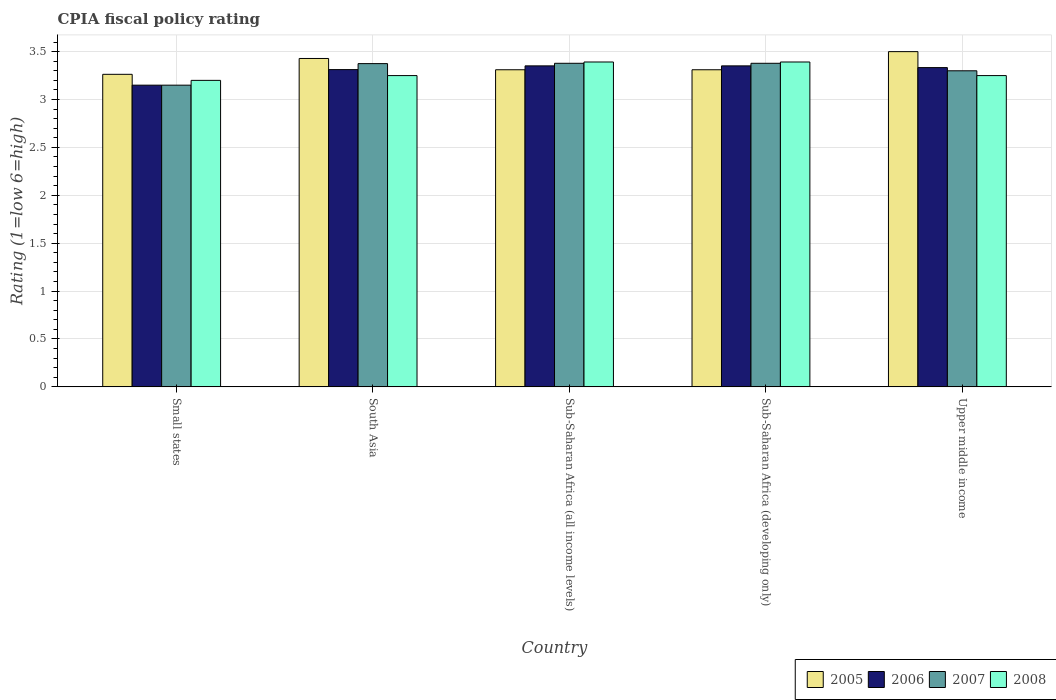How many groups of bars are there?
Keep it short and to the point. 5. How many bars are there on the 5th tick from the left?
Your response must be concise. 4. How many bars are there on the 5th tick from the right?
Give a very brief answer. 4. What is the label of the 3rd group of bars from the left?
Your response must be concise. Sub-Saharan Africa (all income levels). In how many cases, is the number of bars for a given country not equal to the number of legend labels?
Your response must be concise. 0. What is the CPIA rating in 2006 in Small states?
Offer a very short reply. 3.15. Across all countries, what is the maximum CPIA rating in 2006?
Offer a terse response. 3.35. Across all countries, what is the minimum CPIA rating in 2006?
Provide a short and direct response. 3.15. In which country was the CPIA rating in 2005 maximum?
Give a very brief answer. Upper middle income. In which country was the CPIA rating in 2007 minimum?
Ensure brevity in your answer.  Small states. What is the total CPIA rating in 2005 in the graph?
Provide a succinct answer. 16.81. What is the difference between the CPIA rating in 2006 in Small states and that in South Asia?
Your response must be concise. -0.16. What is the difference between the CPIA rating in 2008 in Sub-Saharan Africa (developing only) and the CPIA rating in 2007 in Sub-Saharan Africa (all income levels)?
Your response must be concise. 0.01. What is the average CPIA rating in 2008 per country?
Give a very brief answer. 3.3. What is the difference between the CPIA rating of/in 2006 and CPIA rating of/in 2007 in Sub-Saharan Africa (developing only)?
Your answer should be very brief. -0.03. Is the CPIA rating in 2007 in Sub-Saharan Africa (developing only) less than that in Upper middle income?
Keep it short and to the point. No. Is the difference between the CPIA rating in 2006 in Sub-Saharan Africa (all income levels) and Sub-Saharan Africa (developing only) greater than the difference between the CPIA rating in 2007 in Sub-Saharan Africa (all income levels) and Sub-Saharan Africa (developing only)?
Provide a short and direct response. No. What is the difference between the highest and the second highest CPIA rating in 2006?
Your answer should be compact. -0.02. What is the difference between the highest and the lowest CPIA rating in 2006?
Your answer should be very brief. 0.2. In how many countries, is the CPIA rating in 2008 greater than the average CPIA rating in 2008 taken over all countries?
Your response must be concise. 2. Is it the case that in every country, the sum of the CPIA rating in 2006 and CPIA rating in 2005 is greater than the sum of CPIA rating in 2008 and CPIA rating in 2007?
Give a very brief answer. No. What does the 2nd bar from the right in Sub-Saharan Africa (all income levels) represents?
Offer a very short reply. 2007. Is it the case that in every country, the sum of the CPIA rating in 2006 and CPIA rating in 2008 is greater than the CPIA rating in 2007?
Give a very brief answer. Yes. Are all the bars in the graph horizontal?
Provide a succinct answer. No. What is the difference between two consecutive major ticks on the Y-axis?
Make the answer very short. 0.5. Are the values on the major ticks of Y-axis written in scientific E-notation?
Give a very brief answer. No. Does the graph contain grids?
Provide a succinct answer. Yes. Where does the legend appear in the graph?
Offer a very short reply. Bottom right. How are the legend labels stacked?
Make the answer very short. Horizontal. What is the title of the graph?
Provide a short and direct response. CPIA fiscal policy rating. Does "1999" appear as one of the legend labels in the graph?
Provide a short and direct response. No. What is the label or title of the X-axis?
Provide a succinct answer. Country. What is the Rating (1=low 6=high) in 2005 in Small states?
Your response must be concise. 3.26. What is the Rating (1=low 6=high) in 2006 in Small states?
Ensure brevity in your answer.  3.15. What is the Rating (1=low 6=high) of 2007 in Small states?
Offer a very short reply. 3.15. What is the Rating (1=low 6=high) in 2008 in Small states?
Offer a terse response. 3.2. What is the Rating (1=low 6=high) in 2005 in South Asia?
Offer a terse response. 3.43. What is the Rating (1=low 6=high) of 2006 in South Asia?
Your answer should be compact. 3.31. What is the Rating (1=low 6=high) of 2007 in South Asia?
Give a very brief answer. 3.38. What is the Rating (1=low 6=high) in 2005 in Sub-Saharan Africa (all income levels)?
Keep it short and to the point. 3.31. What is the Rating (1=low 6=high) in 2006 in Sub-Saharan Africa (all income levels)?
Provide a short and direct response. 3.35. What is the Rating (1=low 6=high) of 2007 in Sub-Saharan Africa (all income levels)?
Offer a very short reply. 3.38. What is the Rating (1=low 6=high) in 2008 in Sub-Saharan Africa (all income levels)?
Provide a succinct answer. 3.39. What is the Rating (1=low 6=high) in 2005 in Sub-Saharan Africa (developing only)?
Provide a short and direct response. 3.31. What is the Rating (1=low 6=high) of 2006 in Sub-Saharan Africa (developing only)?
Ensure brevity in your answer.  3.35. What is the Rating (1=low 6=high) in 2007 in Sub-Saharan Africa (developing only)?
Offer a terse response. 3.38. What is the Rating (1=low 6=high) in 2008 in Sub-Saharan Africa (developing only)?
Your answer should be very brief. 3.39. What is the Rating (1=low 6=high) of 2005 in Upper middle income?
Your answer should be compact. 3.5. What is the Rating (1=low 6=high) in 2006 in Upper middle income?
Give a very brief answer. 3.33. Across all countries, what is the maximum Rating (1=low 6=high) in 2006?
Your answer should be compact. 3.35. Across all countries, what is the maximum Rating (1=low 6=high) of 2007?
Keep it short and to the point. 3.38. Across all countries, what is the maximum Rating (1=low 6=high) in 2008?
Give a very brief answer. 3.39. Across all countries, what is the minimum Rating (1=low 6=high) of 2005?
Your response must be concise. 3.26. Across all countries, what is the minimum Rating (1=low 6=high) of 2006?
Ensure brevity in your answer.  3.15. Across all countries, what is the minimum Rating (1=low 6=high) in 2007?
Offer a very short reply. 3.15. What is the total Rating (1=low 6=high) in 2005 in the graph?
Offer a terse response. 16.81. What is the total Rating (1=low 6=high) of 2006 in the graph?
Provide a short and direct response. 16.5. What is the total Rating (1=low 6=high) in 2007 in the graph?
Keep it short and to the point. 16.58. What is the total Rating (1=low 6=high) in 2008 in the graph?
Ensure brevity in your answer.  16.48. What is the difference between the Rating (1=low 6=high) in 2005 in Small states and that in South Asia?
Give a very brief answer. -0.17. What is the difference between the Rating (1=low 6=high) in 2006 in Small states and that in South Asia?
Your response must be concise. -0.16. What is the difference between the Rating (1=low 6=high) of 2007 in Small states and that in South Asia?
Make the answer very short. -0.23. What is the difference between the Rating (1=low 6=high) in 2005 in Small states and that in Sub-Saharan Africa (all income levels)?
Provide a short and direct response. -0.05. What is the difference between the Rating (1=low 6=high) in 2006 in Small states and that in Sub-Saharan Africa (all income levels)?
Offer a very short reply. -0.2. What is the difference between the Rating (1=low 6=high) of 2007 in Small states and that in Sub-Saharan Africa (all income levels)?
Your answer should be very brief. -0.23. What is the difference between the Rating (1=low 6=high) of 2008 in Small states and that in Sub-Saharan Africa (all income levels)?
Offer a terse response. -0.19. What is the difference between the Rating (1=low 6=high) in 2005 in Small states and that in Sub-Saharan Africa (developing only)?
Your answer should be compact. -0.05. What is the difference between the Rating (1=low 6=high) in 2006 in Small states and that in Sub-Saharan Africa (developing only)?
Your answer should be compact. -0.2. What is the difference between the Rating (1=low 6=high) of 2007 in Small states and that in Sub-Saharan Africa (developing only)?
Make the answer very short. -0.23. What is the difference between the Rating (1=low 6=high) in 2008 in Small states and that in Sub-Saharan Africa (developing only)?
Your response must be concise. -0.19. What is the difference between the Rating (1=low 6=high) in 2005 in Small states and that in Upper middle income?
Make the answer very short. -0.24. What is the difference between the Rating (1=low 6=high) in 2006 in Small states and that in Upper middle income?
Your answer should be very brief. -0.18. What is the difference between the Rating (1=low 6=high) in 2005 in South Asia and that in Sub-Saharan Africa (all income levels)?
Provide a succinct answer. 0.12. What is the difference between the Rating (1=low 6=high) of 2006 in South Asia and that in Sub-Saharan Africa (all income levels)?
Keep it short and to the point. -0.04. What is the difference between the Rating (1=low 6=high) in 2007 in South Asia and that in Sub-Saharan Africa (all income levels)?
Ensure brevity in your answer.  -0. What is the difference between the Rating (1=low 6=high) of 2008 in South Asia and that in Sub-Saharan Africa (all income levels)?
Make the answer very short. -0.14. What is the difference between the Rating (1=low 6=high) in 2005 in South Asia and that in Sub-Saharan Africa (developing only)?
Ensure brevity in your answer.  0.12. What is the difference between the Rating (1=low 6=high) in 2006 in South Asia and that in Sub-Saharan Africa (developing only)?
Ensure brevity in your answer.  -0.04. What is the difference between the Rating (1=low 6=high) in 2007 in South Asia and that in Sub-Saharan Africa (developing only)?
Make the answer very short. -0. What is the difference between the Rating (1=low 6=high) in 2008 in South Asia and that in Sub-Saharan Africa (developing only)?
Your answer should be very brief. -0.14. What is the difference between the Rating (1=low 6=high) in 2005 in South Asia and that in Upper middle income?
Make the answer very short. -0.07. What is the difference between the Rating (1=low 6=high) in 2006 in South Asia and that in Upper middle income?
Your answer should be very brief. -0.02. What is the difference between the Rating (1=low 6=high) in 2007 in South Asia and that in Upper middle income?
Keep it short and to the point. 0.07. What is the difference between the Rating (1=low 6=high) in 2006 in Sub-Saharan Africa (all income levels) and that in Sub-Saharan Africa (developing only)?
Your response must be concise. 0. What is the difference between the Rating (1=low 6=high) of 2007 in Sub-Saharan Africa (all income levels) and that in Sub-Saharan Africa (developing only)?
Provide a succinct answer. 0. What is the difference between the Rating (1=low 6=high) of 2005 in Sub-Saharan Africa (all income levels) and that in Upper middle income?
Ensure brevity in your answer.  -0.19. What is the difference between the Rating (1=low 6=high) in 2006 in Sub-Saharan Africa (all income levels) and that in Upper middle income?
Your response must be concise. 0.02. What is the difference between the Rating (1=low 6=high) in 2007 in Sub-Saharan Africa (all income levels) and that in Upper middle income?
Give a very brief answer. 0.08. What is the difference between the Rating (1=low 6=high) in 2008 in Sub-Saharan Africa (all income levels) and that in Upper middle income?
Your response must be concise. 0.14. What is the difference between the Rating (1=low 6=high) of 2005 in Sub-Saharan Africa (developing only) and that in Upper middle income?
Provide a short and direct response. -0.19. What is the difference between the Rating (1=low 6=high) in 2006 in Sub-Saharan Africa (developing only) and that in Upper middle income?
Your response must be concise. 0.02. What is the difference between the Rating (1=low 6=high) in 2007 in Sub-Saharan Africa (developing only) and that in Upper middle income?
Your response must be concise. 0.08. What is the difference between the Rating (1=low 6=high) in 2008 in Sub-Saharan Africa (developing only) and that in Upper middle income?
Give a very brief answer. 0.14. What is the difference between the Rating (1=low 6=high) in 2005 in Small states and the Rating (1=low 6=high) in 2006 in South Asia?
Offer a very short reply. -0.05. What is the difference between the Rating (1=low 6=high) of 2005 in Small states and the Rating (1=low 6=high) of 2007 in South Asia?
Give a very brief answer. -0.11. What is the difference between the Rating (1=low 6=high) of 2005 in Small states and the Rating (1=low 6=high) of 2008 in South Asia?
Your answer should be compact. 0.01. What is the difference between the Rating (1=low 6=high) in 2006 in Small states and the Rating (1=low 6=high) in 2007 in South Asia?
Provide a succinct answer. -0.23. What is the difference between the Rating (1=low 6=high) of 2006 in Small states and the Rating (1=low 6=high) of 2008 in South Asia?
Keep it short and to the point. -0.1. What is the difference between the Rating (1=low 6=high) of 2007 in Small states and the Rating (1=low 6=high) of 2008 in South Asia?
Give a very brief answer. -0.1. What is the difference between the Rating (1=low 6=high) in 2005 in Small states and the Rating (1=low 6=high) in 2006 in Sub-Saharan Africa (all income levels)?
Offer a very short reply. -0.09. What is the difference between the Rating (1=low 6=high) of 2005 in Small states and the Rating (1=low 6=high) of 2007 in Sub-Saharan Africa (all income levels)?
Make the answer very short. -0.12. What is the difference between the Rating (1=low 6=high) in 2005 in Small states and the Rating (1=low 6=high) in 2008 in Sub-Saharan Africa (all income levels)?
Your response must be concise. -0.13. What is the difference between the Rating (1=low 6=high) of 2006 in Small states and the Rating (1=low 6=high) of 2007 in Sub-Saharan Africa (all income levels)?
Your response must be concise. -0.23. What is the difference between the Rating (1=low 6=high) in 2006 in Small states and the Rating (1=low 6=high) in 2008 in Sub-Saharan Africa (all income levels)?
Ensure brevity in your answer.  -0.24. What is the difference between the Rating (1=low 6=high) of 2007 in Small states and the Rating (1=low 6=high) of 2008 in Sub-Saharan Africa (all income levels)?
Your answer should be very brief. -0.24. What is the difference between the Rating (1=low 6=high) of 2005 in Small states and the Rating (1=low 6=high) of 2006 in Sub-Saharan Africa (developing only)?
Offer a very short reply. -0.09. What is the difference between the Rating (1=low 6=high) in 2005 in Small states and the Rating (1=low 6=high) in 2007 in Sub-Saharan Africa (developing only)?
Ensure brevity in your answer.  -0.12. What is the difference between the Rating (1=low 6=high) of 2005 in Small states and the Rating (1=low 6=high) of 2008 in Sub-Saharan Africa (developing only)?
Give a very brief answer. -0.13. What is the difference between the Rating (1=low 6=high) of 2006 in Small states and the Rating (1=low 6=high) of 2007 in Sub-Saharan Africa (developing only)?
Give a very brief answer. -0.23. What is the difference between the Rating (1=low 6=high) of 2006 in Small states and the Rating (1=low 6=high) of 2008 in Sub-Saharan Africa (developing only)?
Keep it short and to the point. -0.24. What is the difference between the Rating (1=low 6=high) of 2007 in Small states and the Rating (1=low 6=high) of 2008 in Sub-Saharan Africa (developing only)?
Provide a succinct answer. -0.24. What is the difference between the Rating (1=low 6=high) of 2005 in Small states and the Rating (1=low 6=high) of 2006 in Upper middle income?
Your response must be concise. -0.07. What is the difference between the Rating (1=low 6=high) in 2005 in Small states and the Rating (1=low 6=high) in 2007 in Upper middle income?
Make the answer very short. -0.04. What is the difference between the Rating (1=low 6=high) of 2005 in Small states and the Rating (1=low 6=high) of 2008 in Upper middle income?
Make the answer very short. 0.01. What is the difference between the Rating (1=low 6=high) in 2006 in Small states and the Rating (1=low 6=high) in 2007 in Upper middle income?
Provide a succinct answer. -0.15. What is the difference between the Rating (1=low 6=high) in 2006 in Small states and the Rating (1=low 6=high) in 2008 in Upper middle income?
Your response must be concise. -0.1. What is the difference between the Rating (1=low 6=high) in 2007 in Small states and the Rating (1=low 6=high) in 2008 in Upper middle income?
Offer a very short reply. -0.1. What is the difference between the Rating (1=low 6=high) of 2005 in South Asia and the Rating (1=low 6=high) of 2006 in Sub-Saharan Africa (all income levels)?
Keep it short and to the point. 0.08. What is the difference between the Rating (1=low 6=high) of 2005 in South Asia and the Rating (1=low 6=high) of 2007 in Sub-Saharan Africa (all income levels)?
Your response must be concise. 0.05. What is the difference between the Rating (1=low 6=high) in 2005 in South Asia and the Rating (1=low 6=high) in 2008 in Sub-Saharan Africa (all income levels)?
Your answer should be very brief. 0.04. What is the difference between the Rating (1=low 6=high) of 2006 in South Asia and the Rating (1=low 6=high) of 2007 in Sub-Saharan Africa (all income levels)?
Give a very brief answer. -0.07. What is the difference between the Rating (1=low 6=high) in 2006 in South Asia and the Rating (1=low 6=high) in 2008 in Sub-Saharan Africa (all income levels)?
Give a very brief answer. -0.08. What is the difference between the Rating (1=low 6=high) in 2007 in South Asia and the Rating (1=low 6=high) in 2008 in Sub-Saharan Africa (all income levels)?
Provide a short and direct response. -0.02. What is the difference between the Rating (1=low 6=high) of 2005 in South Asia and the Rating (1=low 6=high) of 2006 in Sub-Saharan Africa (developing only)?
Ensure brevity in your answer.  0.08. What is the difference between the Rating (1=low 6=high) of 2005 in South Asia and the Rating (1=low 6=high) of 2007 in Sub-Saharan Africa (developing only)?
Ensure brevity in your answer.  0.05. What is the difference between the Rating (1=low 6=high) of 2005 in South Asia and the Rating (1=low 6=high) of 2008 in Sub-Saharan Africa (developing only)?
Your answer should be compact. 0.04. What is the difference between the Rating (1=low 6=high) in 2006 in South Asia and the Rating (1=low 6=high) in 2007 in Sub-Saharan Africa (developing only)?
Keep it short and to the point. -0.07. What is the difference between the Rating (1=low 6=high) of 2006 in South Asia and the Rating (1=low 6=high) of 2008 in Sub-Saharan Africa (developing only)?
Your answer should be very brief. -0.08. What is the difference between the Rating (1=low 6=high) of 2007 in South Asia and the Rating (1=low 6=high) of 2008 in Sub-Saharan Africa (developing only)?
Give a very brief answer. -0.02. What is the difference between the Rating (1=low 6=high) in 2005 in South Asia and the Rating (1=low 6=high) in 2006 in Upper middle income?
Provide a short and direct response. 0.1. What is the difference between the Rating (1=low 6=high) in 2005 in South Asia and the Rating (1=low 6=high) in 2007 in Upper middle income?
Keep it short and to the point. 0.13. What is the difference between the Rating (1=low 6=high) in 2005 in South Asia and the Rating (1=low 6=high) in 2008 in Upper middle income?
Give a very brief answer. 0.18. What is the difference between the Rating (1=low 6=high) of 2006 in South Asia and the Rating (1=low 6=high) of 2007 in Upper middle income?
Your response must be concise. 0.01. What is the difference between the Rating (1=low 6=high) of 2006 in South Asia and the Rating (1=low 6=high) of 2008 in Upper middle income?
Your response must be concise. 0.06. What is the difference between the Rating (1=low 6=high) in 2005 in Sub-Saharan Africa (all income levels) and the Rating (1=low 6=high) in 2006 in Sub-Saharan Africa (developing only)?
Keep it short and to the point. -0.04. What is the difference between the Rating (1=low 6=high) in 2005 in Sub-Saharan Africa (all income levels) and the Rating (1=low 6=high) in 2007 in Sub-Saharan Africa (developing only)?
Ensure brevity in your answer.  -0.07. What is the difference between the Rating (1=low 6=high) in 2005 in Sub-Saharan Africa (all income levels) and the Rating (1=low 6=high) in 2008 in Sub-Saharan Africa (developing only)?
Provide a succinct answer. -0.08. What is the difference between the Rating (1=low 6=high) in 2006 in Sub-Saharan Africa (all income levels) and the Rating (1=low 6=high) in 2007 in Sub-Saharan Africa (developing only)?
Make the answer very short. -0.03. What is the difference between the Rating (1=low 6=high) in 2006 in Sub-Saharan Africa (all income levels) and the Rating (1=low 6=high) in 2008 in Sub-Saharan Africa (developing only)?
Ensure brevity in your answer.  -0.04. What is the difference between the Rating (1=low 6=high) of 2007 in Sub-Saharan Africa (all income levels) and the Rating (1=low 6=high) of 2008 in Sub-Saharan Africa (developing only)?
Your answer should be very brief. -0.01. What is the difference between the Rating (1=low 6=high) in 2005 in Sub-Saharan Africa (all income levels) and the Rating (1=low 6=high) in 2006 in Upper middle income?
Ensure brevity in your answer.  -0.02. What is the difference between the Rating (1=low 6=high) of 2005 in Sub-Saharan Africa (all income levels) and the Rating (1=low 6=high) of 2007 in Upper middle income?
Offer a very short reply. 0.01. What is the difference between the Rating (1=low 6=high) of 2005 in Sub-Saharan Africa (all income levels) and the Rating (1=low 6=high) of 2008 in Upper middle income?
Your response must be concise. 0.06. What is the difference between the Rating (1=low 6=high) in 2006 in Sub-Saharan Africa (all income levels) and the Rating (1=low 6=high) in 2007 in Upper middle income?
Keep it short and to the point. 0.05. What is the difference between the Rating (1=low 6=high) in 2006 in Sub-Saharan Africa (all income levels) and the Rating (1=low 6=high) in 2008 in Upper middle income?
Provide a succinct answer. 0.1. What is the difference between the Rating (1=low 6=high) of 2007 in Sub-Saharan Africa (all income levels) and the Rating (1=low 6=high) of 2008 in Upper middle income?
Provide a short and direct response. 0.13. What is the difference between the Rating (1=low 6=high) of 2005 in Sub-Saharan Africa (developing only) and the Rating (1=low 6=high) of 2006 in Upper middle income?
Offer a very short reply. -0.02. What is the difference between the Rating (1=low 6=high) in 2005 in Sub-Saharan Africa (developing only) and the Rating (1=low 6=high) in 2007 in Upper middle income?
Offer a very short reply. 0.01. What is the difference between the Rating (1=low 6=high) in 2005 in Sub-Saharan Africa (developing only) and the Rating (1=low 6=high) in 2008 in Upper middle income?
Give a very brief answer. 0.06. What is the difference between the Rating (1=low 6=high) of 2006 in Sub-Saharan Africa (developing only) and the Rating (1=low 6=high) of 2007 in Upper middle income?
Provide a short and direct response. 0.05. What is the difference between the Rating (1=low 6=high) of 2006 in Sub-Saharan Africa (developing only) and the Rating (1=low 6=high) of 2008 in Upper middle income?
Offer a very short reply. 0.1. What is the difference between the Rating (1=low 6=high) of 2007 in Sub-Saharan Africa (developing only) and the Rating (1=low 6=high) of 2008 in Upper middle income?
Your response must be concise. 0.13. What is the average Rating (1=low 6=high) in 2005 per country?
Provide a short and direct response. 3.36. What is the average Rating (1=low 6=high) of 2006 per country?
Provide a succinct answer. 3.3. What is the average Rating (1=low 6=high) in 2007 per country?
Give a very brief answer. 3.32. What is the average Rating (1=low 6=high) of 2008 per country?
Provide a succinct answer. 3.3. What is the difference between the Rating (1=low 6=high) in 2005 and Rating (1=low 6=high) in 2006 in Small states?
Your answer should be very brief. 0.11. What is the difference between the Rating (1=low 6=high) in 2005 and Rating (1=low 6=high) in 2007 in Small states?
Your answer should be compact. 0.11. What is the difference between the Rating (1=low 6=high) of 2005 and Rating (1=low 6=high) of 2008 in Small states?
Your answer should be compact. 0.06. What is the difference between the Rating (1=low 6=high) in 2006 and Rating (1=low 6=high) in 2007 in Small states?
Offer a very short reply. 0. What is the difference between the Rating (1=low 6=high) in 2006 and Rating (1=low 6=high) in 2008 in Small states?
Your response must be concise. -0.05. What is the difference between the Rating (1=low 6=high) of 2005 and Rating (1=low 6=high) of 2006 in South Asia?
Give a very brief answer. 0.12. What is the difference between the Rating (1=low 6=high) in 2005 and Rating (1=low 6=high) in 2007 in South Asia?
Provide a short and direct response. 0.05. What is the difference between the Rating (1=low 6=high) of 2005 and Rating (1=low 6=high) of 2008 in South Asia?
Keep it short and to the point. 0.18. What is the difference between the Rating (1=low 6=high) in 2006 and Rating (1=low 6=high) in 2007 in South Asia?
Provide a short and direct response. -0.06. What is the difference between the Rating (1=low 6=high) in 2006 and Rating (1=low 6=high) in 2008 in South Asia?
Your response must be concise. 0.06. What is the difference between the Rating (1=low 6=high) in 2007 and Rating (1=low 6=high) in 2008 in South Asia?
Provide a short and direct response. 0.12. What is the difference between the Rating (1=low 6=high) of 2005 and Rating (1=low 6=high) of 2006 in Sub-Saharan Africa (all income levels)?
Your answer should be compact. -0.04. What is the difference between the Rating (1=low 6=high) of 2005 and Rating (1=low 6=high) of 2007 in Sub-Saharan Africa (all income levels)?
Your answer should be very brief. -0.07. What is the difference between the Rating (1=low 6=high) of 2005 and Rating (1=low 6=high) of 2008 in Sub-Saharan Africa (all income levels)?
Offer a very short reply. -0.08. What is the difference between the Rating (1=low 6=high) of 2006 and Rating (1=low 6=high) of 2007 in Sub-Saharan Africa (all income levels)?
Ensure brevity in your answer.  -0.03. What is the difference between the Rating (1=low 6=high) in 2006 and Rating (1=low 6=high) in 2008 in Sub-Saharan Africa (all income levels)?
Keep it short and to the point. -0.04. What is the difference between the Rating (1=low 6=high) in 2007 and Rating (1=low 6=high) in 2008 in Sub-Saharan Africa (all income levels)?
Provide a short and direct response. -0.01. What is the difference between the Rating (1=low 6=high) in 2005 and Rating (1=low 6=high) in 2006 in Sub-Saharan Africa (developing only)?
Offer a very short reply. -0.04. What is the difference between the Rating (1=low 6=high) in 2005 and Rating (1=low 6=high) in 2007 in Sub-Saharan Africa (developing only)?
Give a very brief answer. -0.07. What is the difference between the Rating (1=low 6=high) in 2005 and Rating (1=low 6=high) in 2008 in Sub-Saharan Africa (developing only)?
Your response must be concise. -0.08. What is the difference between the Rating (1=low 6=high) in 2006 and Rating (1=low 6=high) in 2007 in Sub-Saharan Africa (developing only)?
Provide a succinct answer. -0.03. What is the difference between the Rating (1=low 6=high) in 2006 and Rating (1=low 6=high) in 2008 in Sub-Saharan Africa (developing only)?
Give a very brief answer. -0.04. What is the difference between the Rating (1=low 6=high) of 2007 and Rating (1=low 6=high) of 2008 in Sub-Saharan Africa (developing only)?
Your response must be concise. -0.01. What is the difference between the Rating (1=low 6=high) in 2005 and Rating (1=low 6=high) in 2006 in Upper middle income?
Your response must be concise. 0.17. What is the difference between the Rating (1=low 6=high) in 2005 and Rating (1=low 6=high) in 2007 in Upper middle income?
Give a very brief answer. 0.2. What is the difference between the Rating (1=low 6=high) of 2006 and Rating (1=low 6=high) of 2007 in Upper middle income?
Give a very brief answer. 0.03. What is the difference between the Rating (1=low 6=high) in 2006 and Rating (1=low 6=high) in 2008 in Upper middle income?
Offer a terse response. 0.08. What is the difference between the Rating (1=low 6=high) of 2007 and Rating (1=low 6=high) of 2008 in Upper middle income?
Your answer should be very brief. 0.05. What is the ratio of the Rating (1=low 6=high) of 2005 in Small states to that in South Asia?
Offer a very short reply. 0.95. What is the ratio of the Rating (1=low 6=high) in 2006 in Small states to that in South Asia?
Offer a terse response. 0.95. What is the ratio of the Rating (1=low 6=high) in 2008 in Small states to that in South Asia?
Give a very brief answer. 0.98. What is the ratio of the Rating (1=low 6=high) of 2005 in Small states to that in Sub-Saharan Africa (all income levels)?
Provide a short and direct response. 0.99. What is the ratio of the Rating (1=low 6=high) in 2006 in Small states to that in Sub-Saharan Africa (all income levels)?
Make the answer very short. 0.94. What is the ratio of the Rating (1=low 6=high) in 2007 in Small states to that in Sub-Saharan Africa (all income levels)?
Give a very brief answer. 0.93. What is the ratio of the Rating (1=low 6=high) in 2008 in Small states to that in Sub-Saharan Africa (all income levels)?
Your answer should be compact. 0.94. What is the ratio of the Rating (1=low 6=high) in 2005 in Small states to that in Sub-Saharan Africa (developing only)?
Offer a very short reply. 0.99. What is the ratio of the Rating (1=low 6=high) in 2006 in Small states to that in Sub-Saharan Africa (developing only)?
Your answer should be compact. 0.94. What is the ratio of the Rating (1=low 6=high) in 2007 in Small states to that in Sub-Saharan Africa (developing only)?
Offer a very short reply. 0.93. What is the ratio of the Rating (1=low 6=high) of 2008 in Small states to that in Sub-Saharan Africa (developing only)?
Your answer should be compact. 0.94. What is the ratio of the Rating (1=low 6=high) of 2005 in Small states to that in Upper middle income?
Your response must be concise. 0.93. What is the ratio of the Rating (1=low 6=high) of 2006 in Small states to that in Upper middle income?
Ensure brevity in your answer.  0.94. What is the ratio of the Rating (1=low 6=high) in 2007 in Small states to that in Upper middle income?
Provide a succinct answer. 0.95. What is the ratio of the Rating (1=low 6=high) of 2008 in Small states to that in Upper middle income?
Your answer should be compact. 0.98. What is the ratio of the Rating (1=low 6=high) in 2005 in South Asia to that in Sub-Saharan Africa (all income levels)?
Offer a very short reply. 1.04. What is the ratio of the Rating (1=low 6=high) of 2006 in South Asia to that in Sub-Saharan Africa (all income levels)?
Ensure brevity in your answer.  0.99. What is the ratio of the Rating (1=low 6=high) of 2007 in South Asia to that in Sub-Saharan Africa (all income levels)?
Offer a very short reply. 1. What is the ratio of the Rating (1=low 6=high) in 2008 in South Asia to that in Sub-Saharan Africa (all income levels)?
Make the answer very short. 0.96. What is the ratio of the Rating (1=low 6=high) in 2005 in South Asia to that in Sub-Saharan Africa (developing only)?
Give a very brief answer. 1.04. What is the ratio of the Rating (1=low 6=high) in 2006 in South Asia to that in Sub-Saharan Africa (developing only)?
Ensure brevity in your answer.  0.99. What is the ratio of the Rating (1=low 6=high) in 2008 in South Asia to that in Sub-Saharan Africa (developing only)?
Provide a succinct answer. 0.96. What is the ratio of the Rating (1=low 6=high) in 2005 in South Asia to that in Upper middle income?
Provide a succinct answer. 0.98. What is the ratio of the Rating (1=low 6=high) in 2006 in South Asia to that in Upper middle income?
Your answer should be compact. 0.99. What is the ratio of the Rating (1=low 6=high) in 2007 in South Asia to that in Upper middle income?
Make the answer very short. 1.02. What is the ratio of the Rating (1=low 6=high) of 2008 in South Asia to that in Upper middle income?
Offer a terse response. 1. What is the ratio of the Rating (1=low 6=high) of 2005 in Sub-Saharan Africa (all income levels) to that in Sub-Saharan Africa (developing only)?
Offer a very short reply. 1. What is the ratio of the Rating (1=low 6=high) in 2006 in Sub-Saharan Africa (all income levels) to that in Sub-Saharan Africa (developing only)?
Your answer should be very brief. 1. What is the ratio of the Rating (1=low 6=high) in 2007 in Sub-Saharan Africa (all income levels) to that in Sub-Saharan Africa (developing only)?
Provide a succinct answer. 1. What is the ratio of the Rating (1=low 6=high) in 2005 in Sub-Saharan Africa (all income levels) to that in Upper middle income?
Make the answer very short. 0.95. What is the ratio of the Rating (1=low 6=high) in 2006 in Sub-Saharan Africa (all income levels) to that in Upper middle income?
Ensure brevity in your answer.  1.01. What is the ratio of the Rating (1=low 6=high) in 2007 in Sub-Saharan Africa (all income levels) to that in Upper middle income?
Ensure brevity in your answer.  1.02. What is the ratio of the Rating (1=low 6=high) of 2008 in Sub-Saharan Africa (all income levels) to that in Upper middle income?
Keep it short and to the point. 1.04. What is the ratio of the Rating (1=low 6=high) in 2005 in Sub-Saharan Africa (developing only) to that in Upper middle income?
Provide a succinct answer. 0.95. What is the ratio of the Rating (1=low 6=high) in 2006 in Sub-Saharan Africa (developing only) to that in Upper middle income?
Give a very brief answer. 1.01. What is the ratio of the Rating (1=low 6=high) in 2007 in Sub-Saharan Africa (developing only) to that in Upper middle income?
Keep it short and to the point. 1.02. What is the ratio of the Rating (1=low 6=high) in 2008 in Sub-Saharan Africa (developing only) to that in Upper middle income?
Offer a terse response. 1.04. What is the difference between the highest and the second highest Rating (1=low 6=high) of 2005?
Offer a very short reply. 0.07. What is the difference between the highest and the second highest Rating (1=low 6=high) in 2008?
Your answer should be compact. 0. What is the difference between the highest and the lowest Rating (1=low 6=high) in 2005?
Your answer should be very brief. 0.24. What is the difference between the highest and the lowest Rating (1=low 6=high) of 2006?
Provide a short and direct response. 0.2. What is the difference between the highest and the lowest Rating (1=low 6=high) in 2007?
Provide a short and direct response. 0.23. What is the difference between the highest and the lowest Rating (1=low 6=high) of 2008?
Ensure brevity in your answer.  0.19. 